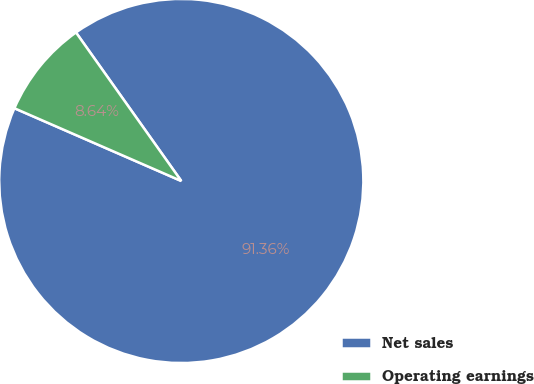Convert chart. <chart><loc_0><loc_0><loc_500><loc_500><pie_chart><fcel>Net sales<fcel>Operating earnings<nl><fcel>91.36%<fcel>8.64%<nl></chart> 